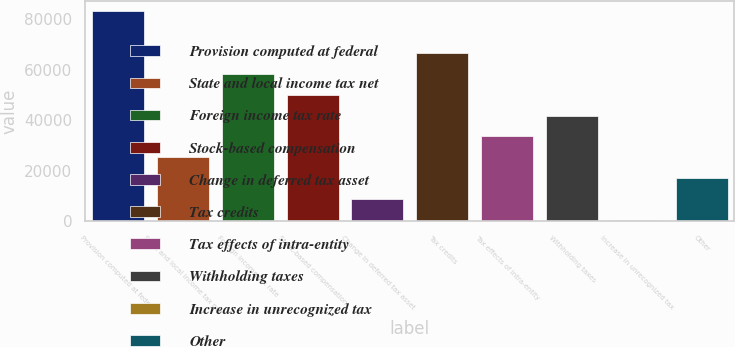Convert chart to OTSL. <chart><loc_0><loc_0><loc_500><loc_500><bar_chart><fcel>Provision computed at federal<fcel>State and local income tax net<fcel>Foreign income tax rate<fcel>Stock-based compensation<fcel>Change in deferred tax asset<fcel>Tax credits<fcel>Tax effects of intra-entity<fcel>Withholding taxes<fcel>Increase in unrecognized tax<fcel>Other<nl><fcel>83003<fcel>25330.7<fcel>58286.3<fcel>50047.4<fcel>8852.9<fcel>66525.2<fcel>33569.6<fcel>41808.5<fcel>614<fcel>17091.8<nl></chart> 